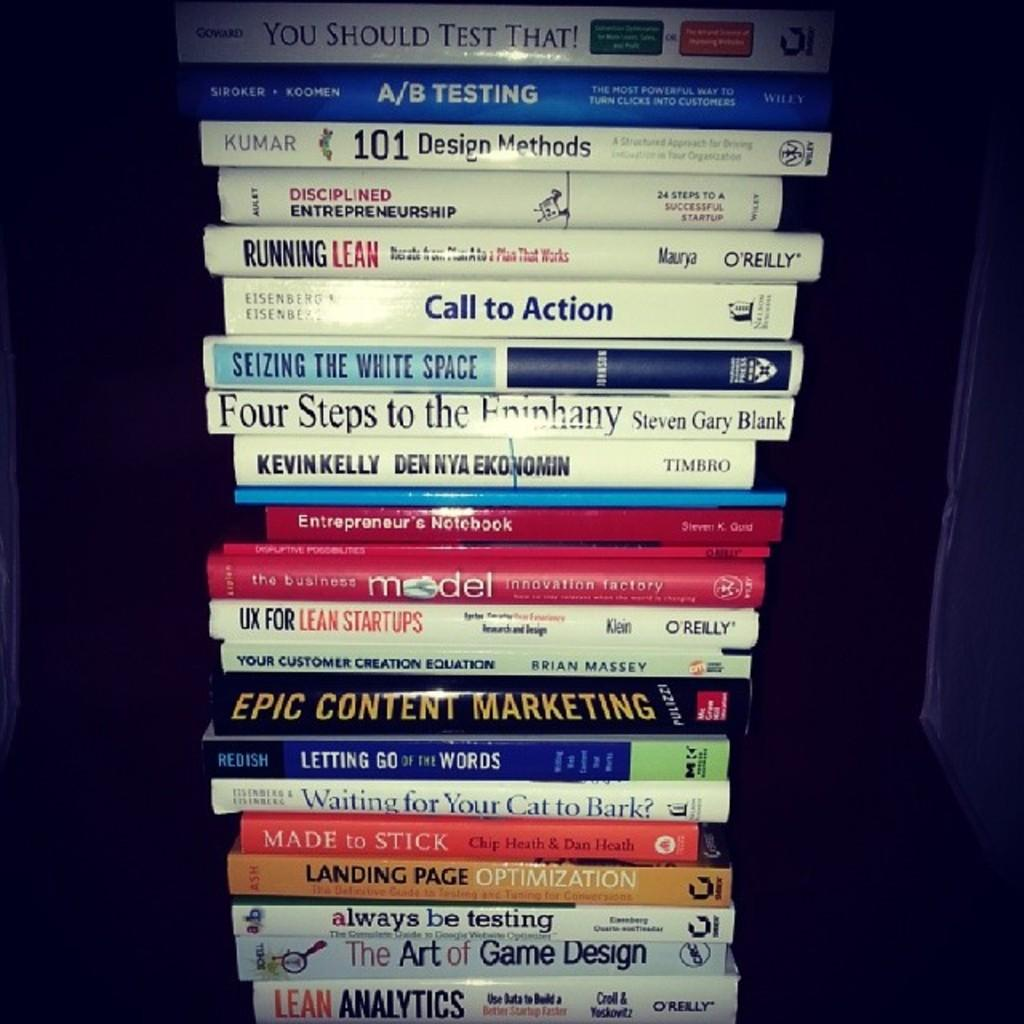<image>
Provide a brief description of the given image. A tall stack of books with one titled Call to Action. 